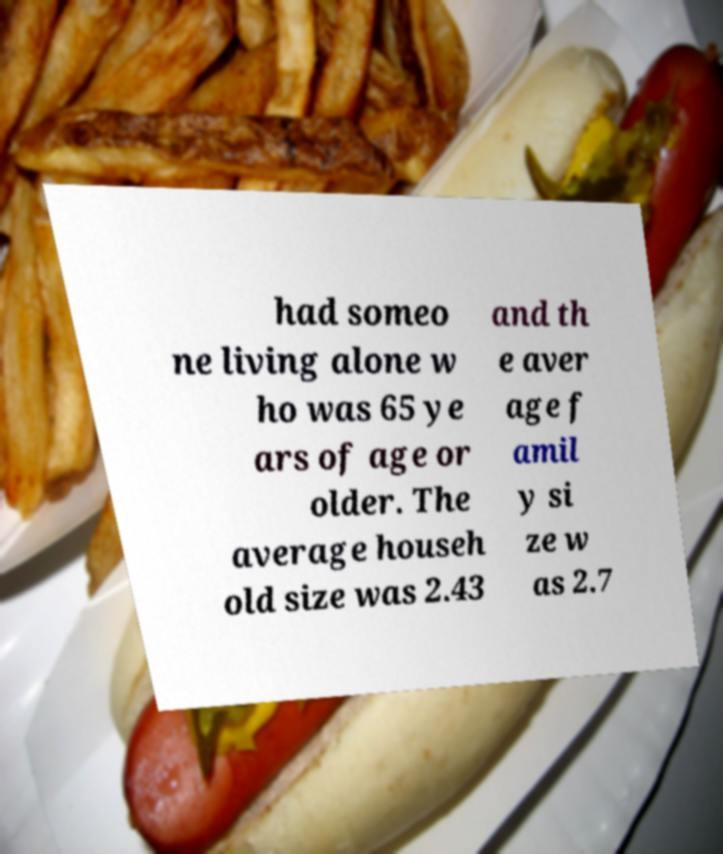Can you accurately transcribe the text from the provided image for me? had someo ne living alone w ho was 65 ye ars of age or older. The average househ old size was 2.43 and th e aver age f amil y si ze w as 2.7 